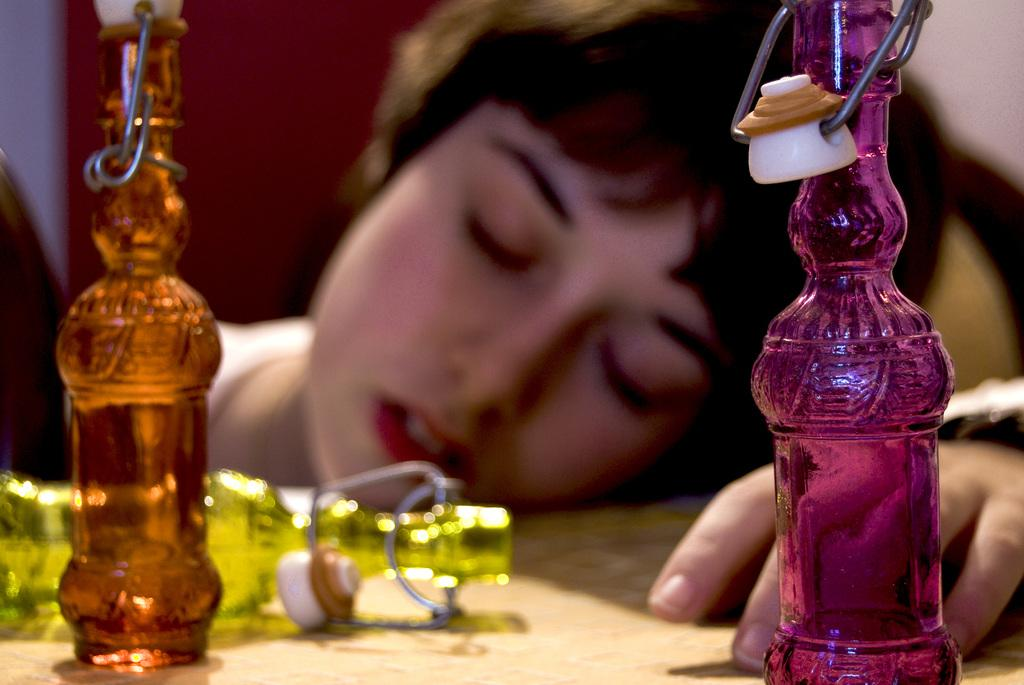What is the position of the woman in the image? The woman is lying on the table in the image. What colors of bottles are present on the table? There is a pink bottle, an orange bottle, and a yellow bottle on the table. What type of soda is being prepared on the stove in the image? There is no stove or soda present in the image; it only features a woman lying on the table and bottles. 